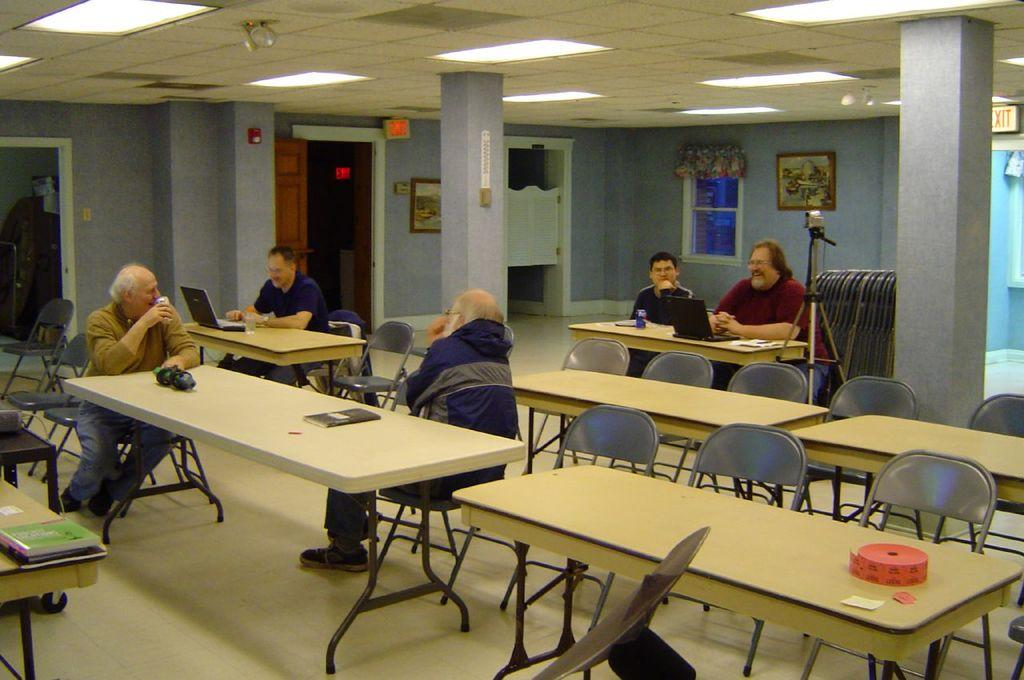How many people are sitting on the chair in the image? There are five people sitting on a chair in the image. What is on the table in the image? There is a laptop and paper on the table in the image. What can be seen in the background of the image? There is a window, a curtain, and a pillar in the background of the image. What type of bomb is visible on the table in the image? There is no bomb present in the image; it features a laptop and paper on the table. Can you tell me how many grandmothers are sitting on the chair in the image? There is no mention of a grandmother in the image; it shows five people sitting on a chair. 